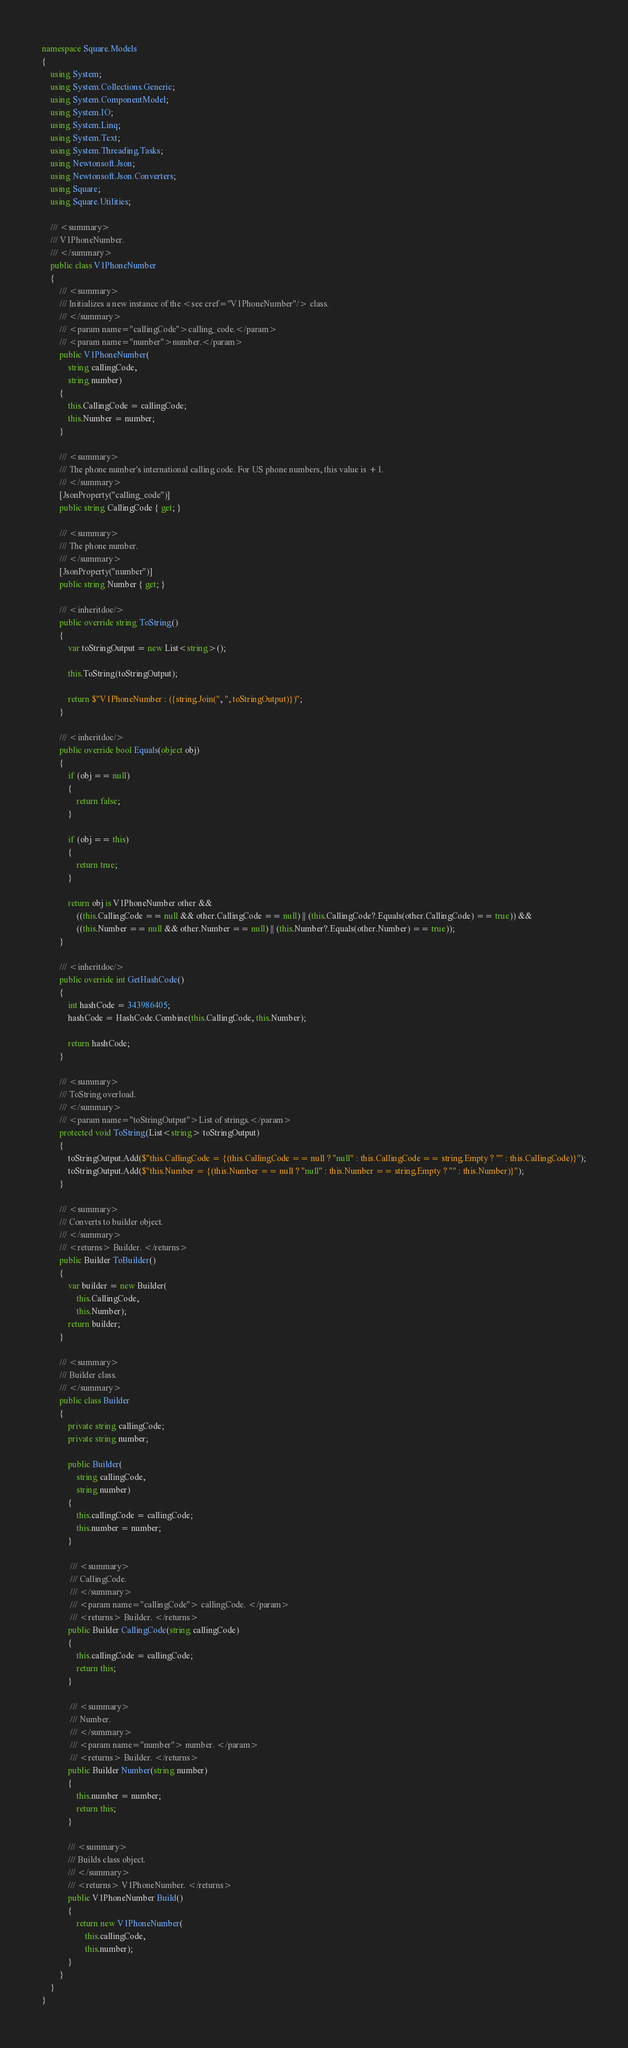Convert code to text. <code><loc_0><loc_0><loc_500><loc_500><_C#_>namespace Square.Models
{
    using System;
    using System.Collections.Generic;
    using System.ComponentModel;
    using System.IO;
    using System.Linq;
    using System.Text;
    using System.Threading.Tasks;
    using Newtonsoft.Json;
    using Newtonsoft.Json.Converters;
    using Square;
    using Square.Utilities;

    /// <summary>
    /// V1PhoneNumber.
    /// </summary>
    public class V1PhoneNumber
    {
        /// <summary>
        /// Initializes a new instance of the <see cref="V1PhoneNumber"/> class.
        /// </summary>
        /// <param name="callingCode">calling_code.</param>
        /// <param name="number">number.</param>
        public V1PhoneNumber(
            string callingCode,
            string number)
        {
            this.CallingCode = callingCode;
            this.Number = number;
        }

        /// <summary>
        /// The phone number's international calling code. For US phone numbers, this value is +1.
        /// </summary>
        [JsonProperty("calling_code")]
        public string CallingCode { get; }

        /// <summary>
        /// The phone number.
        /// </summary>
        [JsonProperty("number")]
        public string Number { get; }

        /// <inheritdoc/>
        public override string ToString()
        {
            var toStringOutput = new List<string>();

            this.ToString(toStringOutput);

            return $"V1PhoneNumber : ({string.Join(", ", toStringOutput)})";
        }

        /// <inheritdoc/>
        public override bool Equals(object obj)
        {
            if (obj == null)
            {
                return false;
            }

            if (obj == this)
            {
                return true;
            }

            return obj is V1PhoneNumber other &&
                ((this.CallingCode == null && other.CallingCode == null) || (this.CallingCode?.Equals(other.CallingCode) == true)) &&
                ((this.Number == null && other.Number == null) || (this.Number?.Equals(other.Number) == true));
        }
        
        /// <inheritdoc/>
        public override int GetHashCode()
        {
            int hashCode = 343986405;
            hashCode = HashCode.Combine(this.CallingCode, this.Number);

            return hashCode;
        }
  
        /// <summary>
        /// ToString overload.
        /// </summary>
        /// <param name="toStringOutput">List of strings.</param>
        protected void ToString(List<string> toStringOutput)
        {
            toStringOutput.Add($"this.CallingCode = {(this.CallingCode == null ? "null" : this.CallingCode == string.Empty ? "" : this.CallingCode)}");
            toStringOutput.Add($"this.Number = {(this.Number == null ? "null" : this.Number == string.Empty ? "" : this.Number)}");
        }

        /// <summary>
        /// Converts to builder object.
        /// </summary>
        /// <returns> Builder. </returns>
        public Builder ToBuilder()
        {
            var builder = new Builder(
                this.CallingCode,
                this.Number);
            return builder;
        }

        /// <summary>
        /// Builder class.
        /// </summary>
        public class Builder
        {
            private string callingCode;
            private string number;

            public Builder(
                string callingCode,
                string number)
            {
                this.callingCode = callingCode;
                this.number = number;
            }

             /// <summary>
             /// CallingCode.
             /// </summary>
             /// <param name="callingCode"> callingCode. </param>
             /// <returns> Builder. </returns>
            public Builder CallingCode(string callingCode)
            {
                this.callingCode = callingCode;
                return this;
            }

             /// <summary>
             /// Number.
             /// </summary>
             /// <param name="number"> number. </param>
             /// <returns> Builder. </returns>
            public Builder Number(string number)
            {
                this.number = number;
                return this;
            }

            /// <summary>
            /// Builds class object.
            /// </summary>
            /// <returns> V1PhoneNumber. </returns>
            public V1PhoneNumber Build()
            {
                return new V1PhoneNumber(
                    this.callingCode,
                    this.number);
            }
        }
    }
}</code> 